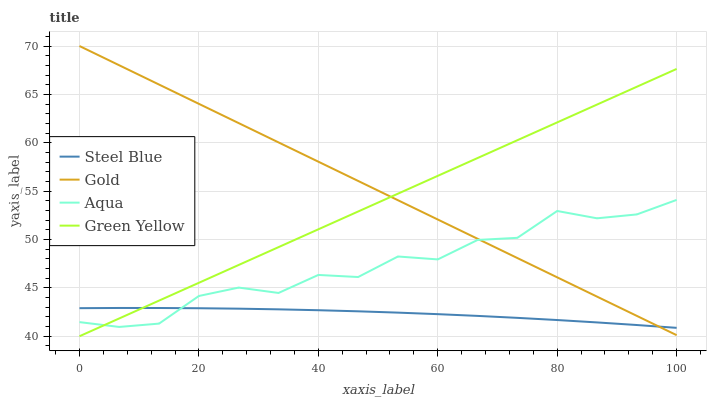Does Steel Blue have the minimum area under the curve?
Answer yes or no. Yes. Does Gold have the maximum area under the curve?
Answer yes or no. Yes. Does Aqua have the minimum area under the curve?
Answer yes or no. No. Does Aqua have the maximum area under the curve?
Answer yes or no. No. Is Green Yellow the smoothest?
Answer yes or no. Yes. Is Aqua the roughest?
Answer yes or no. Yes. Is Steel Blue the smoothest?
Answer yes or no. No. Is Steel Blue the roughest?
Answer yes or no. No. Does Green Yellow have the lowest value?
Answer yes or no. Yes. Does Steel Blue have the lowest value?
Answer yes or no. No. Does Gold have the highest value?
Answer yes or no. Yes. Does Aqua have the highest value?
Answer yes or no. No. Does Aqua intersect Steel Blue?
Answer yes or no. Yes. Is Aqua less than Steel Blue?
Answer yes or no. No. Is Aqua greater than Steel Blue?
Answer yes or no. No. 